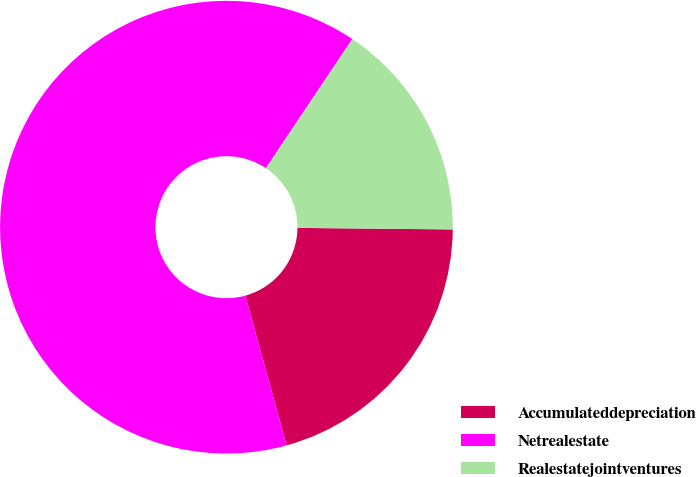Convert chart to OTSL. <chart><loc_0><loc_0><loc_500><loc_500><pie_chart><fcel>Accumulateddepreciation<fcel>Netrealestate<fcel>Realestatejointventures<nl><fcel>20.56%<fcel>63.67%<fcel>15.77%<nl></chart> 